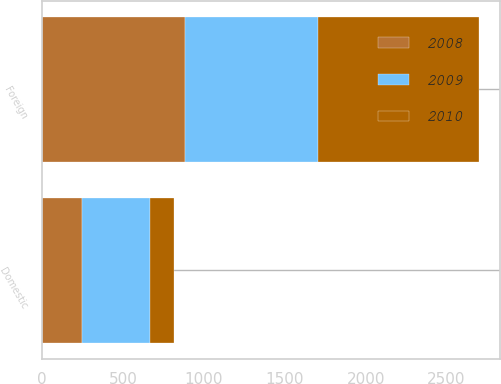Convert chart. <chart><loc_0><loc_0><loc_500><loc_500><stacked_bar_chart><ecel><fcel>Domestic<fcel>Foreign<nl><fcel>2010<fcel>151.4<fcel>993.8<nl><fcel>2008<fcel>249.7<fcel>881.8<nl><fcel>2009<fcel>416.3<fcel>822.4<nl></chart> 